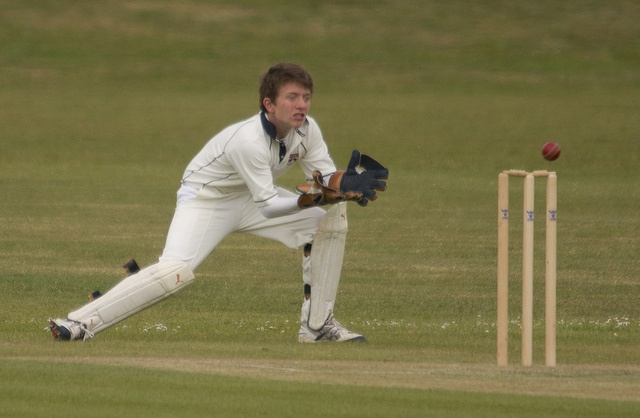Describe the objects in this image and their specific colors. I can see people in olive, darkgray, lightgray, gray, and black tones, baseball glove in olive, black, darkgreen, and gray tones, and sports ball in olive, maroon, brown, and black tones in this image. 